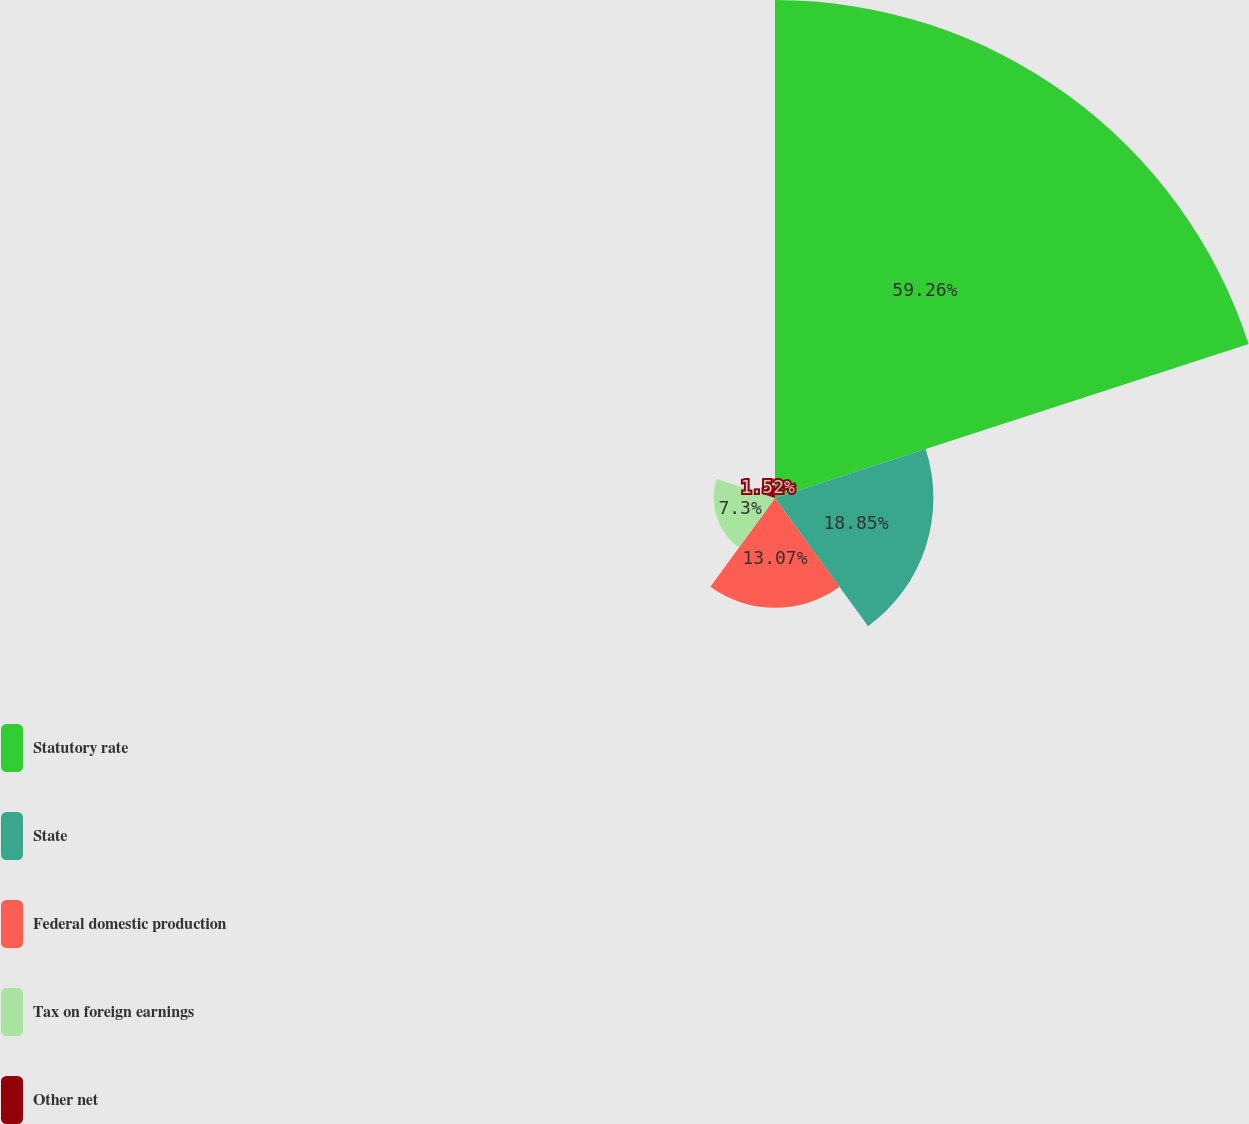<chart> <loc_0><loc_0><loc_500><loc_500><pie_chart><fcel>Statutory rate<fcel>State<fcel>Federal domestic production<fcel>Tax on foreign earnings<fcel>Other net<nl><fcel>59.26%<fcel>18.85%<fcel>13.07%<fcel>7.3%<fcel>1.52%<nl></chart> 